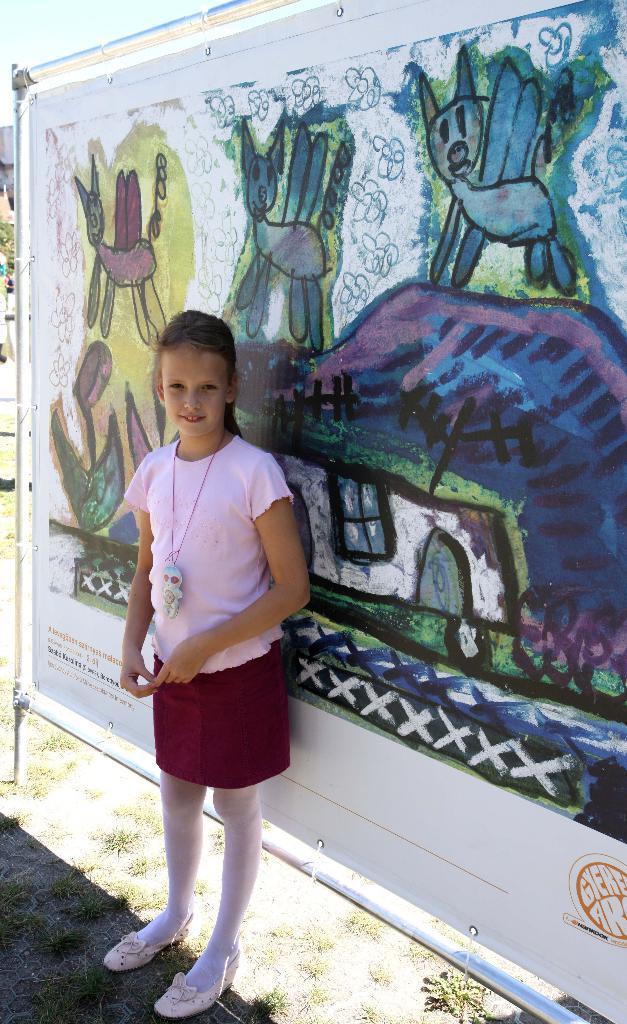How would you summarize this image in a sentence or two? In this image we can see a girl standing on the ground and she is smiling. Here we can see grass. In the background we can see painting on the banner and rods. 